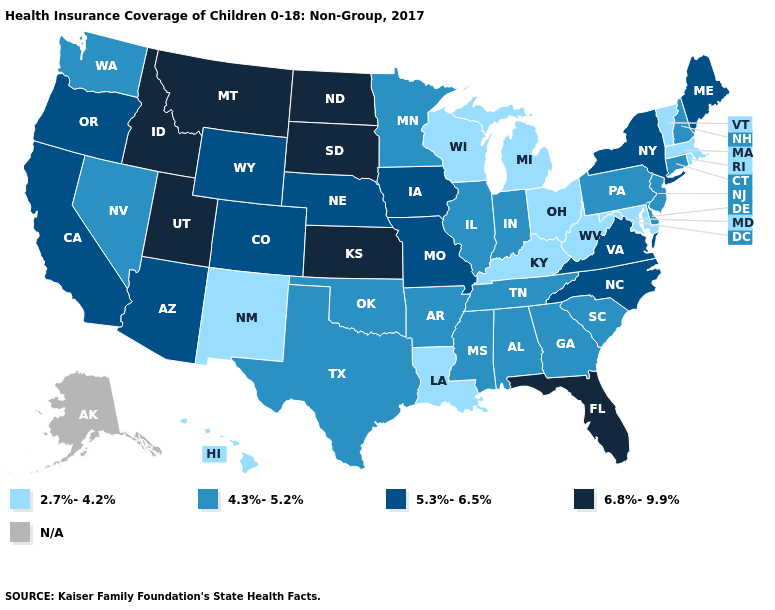What is the highest value in the MidWest ?
Quick response, please. 6.8%-9.9%. Does the first symbol in the legend represent the smallest category?
Be succinct. Yes. What is the highest value in the USA?
Quick response, please. 6.8%-9.9%. Does Montana have the lowest value in the USA?
Concise answer only. No. Name the states that have a value in the range 4.3%-5.2%?
Concise answer only. Alabama, Arkansas, Connecticut, Delaware, Georgia, Illinois, Indiana, Minnesota, Mississippi, Nevada, New Hampshire, New Jersey, Oklahoma, Pennsylvania, South Carolina, Tennessee, Texas, Washington. Name the states that have a value in the range 4.3%-5.2%?
Quick response, please. Alabama, Arkansas, Connecticut, Delaware, Georgia, Illinois, Indiana, Minnesota, Mississippi, Nevada, New Hampshire, New Jersey, Oklahoma, Pennsylvania, South Carolina, Tennessee, Texas, Washington. Does Wisconsin have the lowest value in the USA?
Short answer required. Yes. What is the highest value in the USA?
Quick response, please. 6.8%-9.9%. What is the value of Hawaii?
Concise answer only. 2.7%-4.2%. Does the map have missing data?
Be succinct. Yes. Among the states that border Louisiana , which have the lowest value?
Short answer required. Arkansas, Mississippi, Texas. Among the states that border North Dakota , does Minnesota have the highest value?
Answer briefly. No. What is the value of Texas?
Short answer required. 4.3%-5.2%. What is the highest value in the USA?
Give a very brief answer. 6.8%-9.9%. 